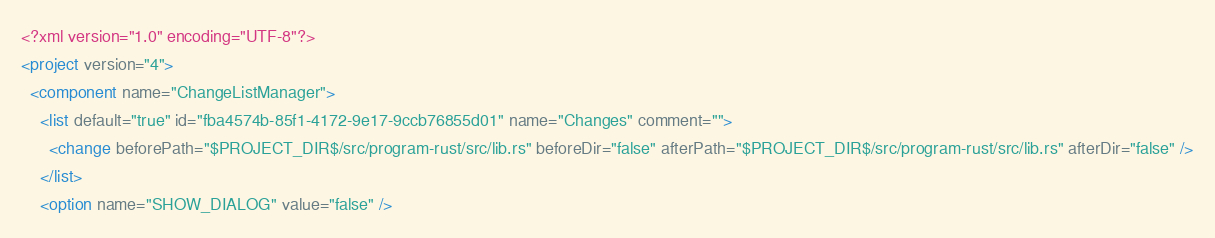<code> <loc_0><loc_0><loc_500><loc_500><_XML_><?xml version="1.0" encoding="UTF-8"?>
<project version="4">
  <component name="ChangeListManager">
    <list default="true" id="fba4574b-85f1-4172-9e17-9ccb76855d01" name="Changes" comment="">
      <change beforePath="$PROJECT_DIR$/src/program-rust/src/lib.rs" beforeDir="false" afterPath="$PROJECT_DIR$/src/program-rust/src/lib.rs" afterDir="false" />
    </list>
    <option name="SHOW_DIALOG" value="false" /></code> 